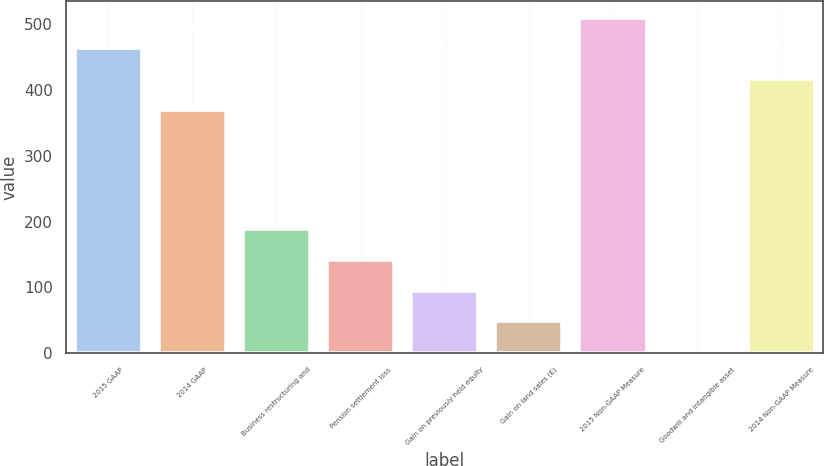Convert chart to OTSL. <chart><loc_0><loc_0><loc_500><loc_500><bar_chart><fcel>2015 GAAP<fcel>2014 GAAP<fcel>Business restructuring and<fcel>Pension settlement loss<fcel>Gain on previously held equity<fcel>Gain on land sales (E)<fcel>2015 Non-GAAP Measure<fcel>Goodwill and intangible asset<fcel>2014 Non-GAAP Measure<nl><fcel>463.28<fcel>369.4<fcel>189.06<fcel>142.12<fcel>95.18<fcel>48.24<fcel>510.22<fcel>1.3<fcel>416.34<nl></chart> 